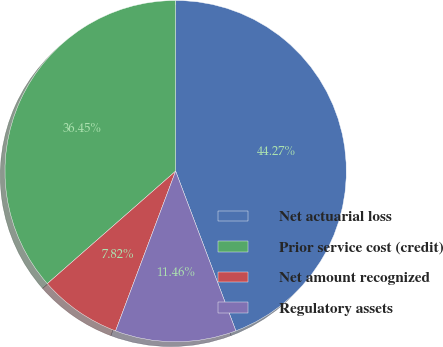Convert chart to OTSL. <chart><loc_0><loc_0><loc_500><loc_500><pie_chart><fcel>Net actuarial loss<fcel>Prior service cost (credit)<fcel>Net amount recognized<fcel>Regulatory assets<nl><fcel>44.27%<fcel>36.45%<fcel>7.82%<fcel>11.46%<nl></chart> 